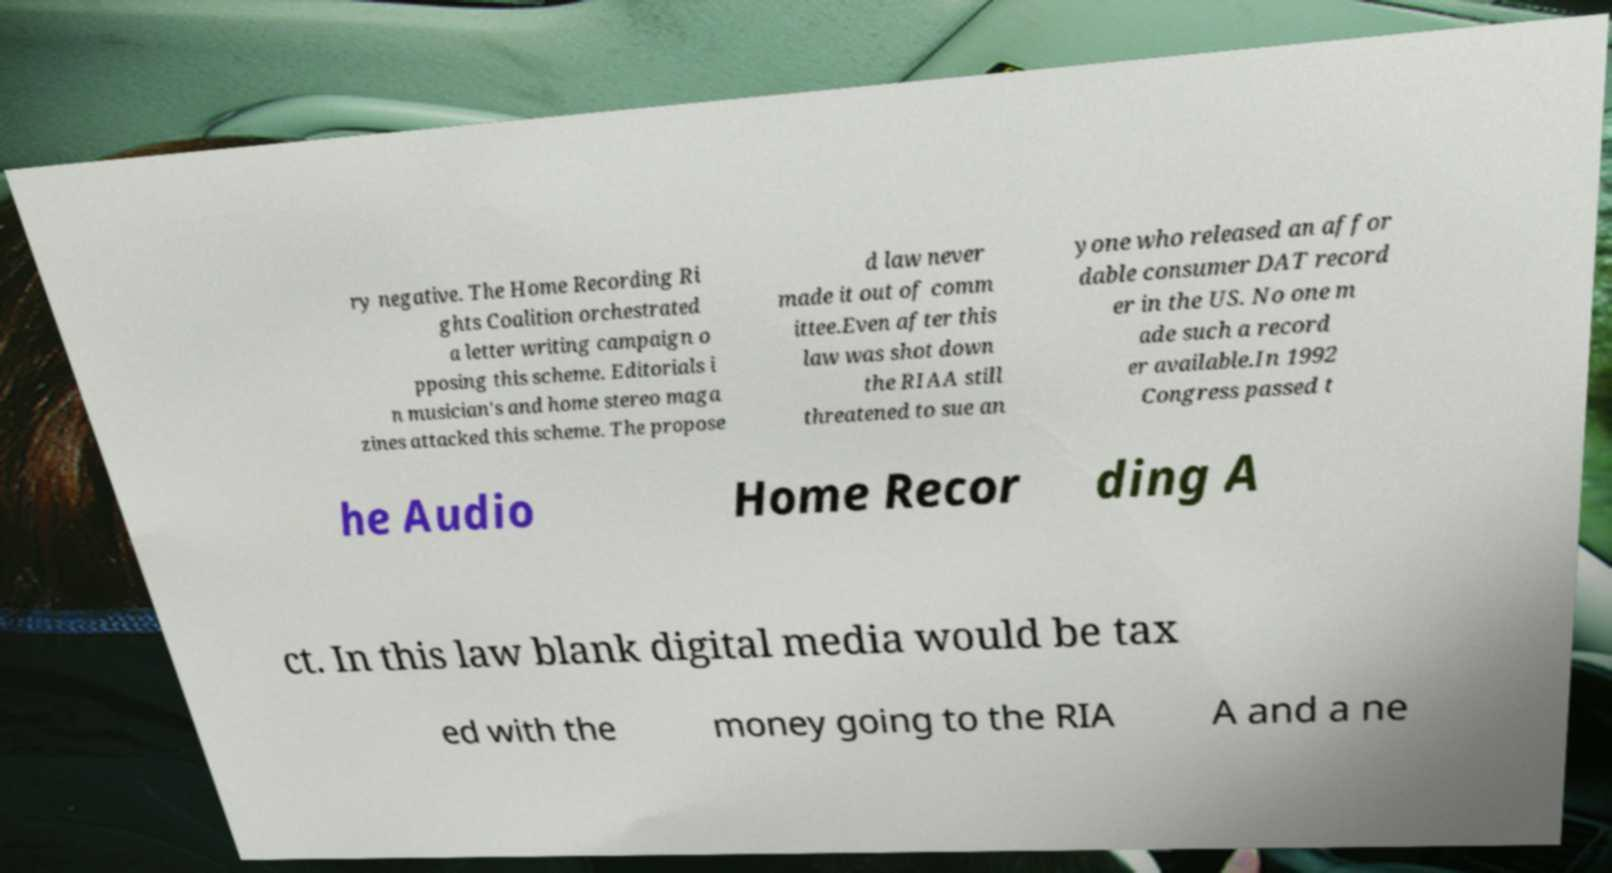There's text embedded in this image that I need extracted. Can you transcribe it verbatim? ry negative. The Home Recording Ri ghts Coalition orchestrated a letter writing campaign o pposing this scheme. Editorials i n musician's and home stereo maga zines attacked this scheme. The propose d law never made it out of comm ittee.Even after this law was shot down the RIAA still threatened to sue an yone who released an affor dable consumer DAT record er in the US. No one m ade such a record er available.In 1992 Congress passed t he Audio Home Recor ding A ct. In this law blank digital media would be tax ed with the money going to the RIA A and a ne 